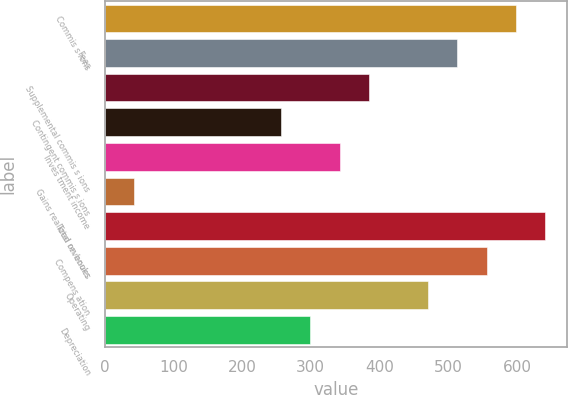Convert chart. <chart><loc_0><loc_0><loc_500><loc_500><bar_chart><fcel>Commis s ions<fcel>Fees<fcel>Supplemental commis s ions<fcel>Contingent commis s ions<fcel>Inves tment income<fcel>Gains realized on books<fcel>Total revenues<fcel>Compens ation<fcel>Operating<fcel>Depreciation<nl><fcel>598.66<fcel>513.16<fcel>384.91<fcel>256.66<fcel>342.16<fcel>42.91<fcel>641.41<fcel>555.91<fcel>470.41<fcel>299.41<nl></chart> 